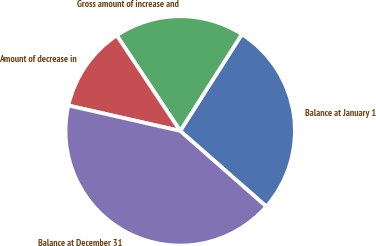<chart> <loc_0><loc_0><loc_500><loc_500><pie_chart><fcel>Balance at January 1<fcel>Gross amount of increase and<fcel>Amount of decrease in<fcel>Balance at December 31<nl><fcel>27.43%<fcel>18.37%<fcel>12.11%<fcel>42.08%<nl></chart> 